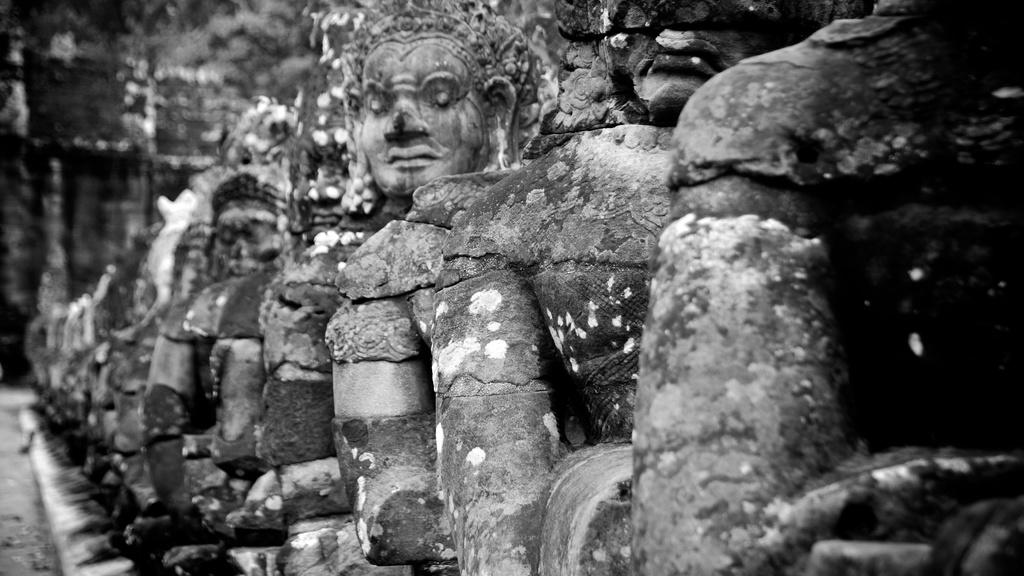What type of art is featured in the image? There are sculptures in the image. Can you describe the background of the image? The background of the image is blurry. What color scheme is used in the image? The image is in black and white. Where is the crate located in the image? There is no crate present in the image. What type of animal can be seen interacting with the sculptures in the image? There are no animals present in the image; it only features sculptures. 